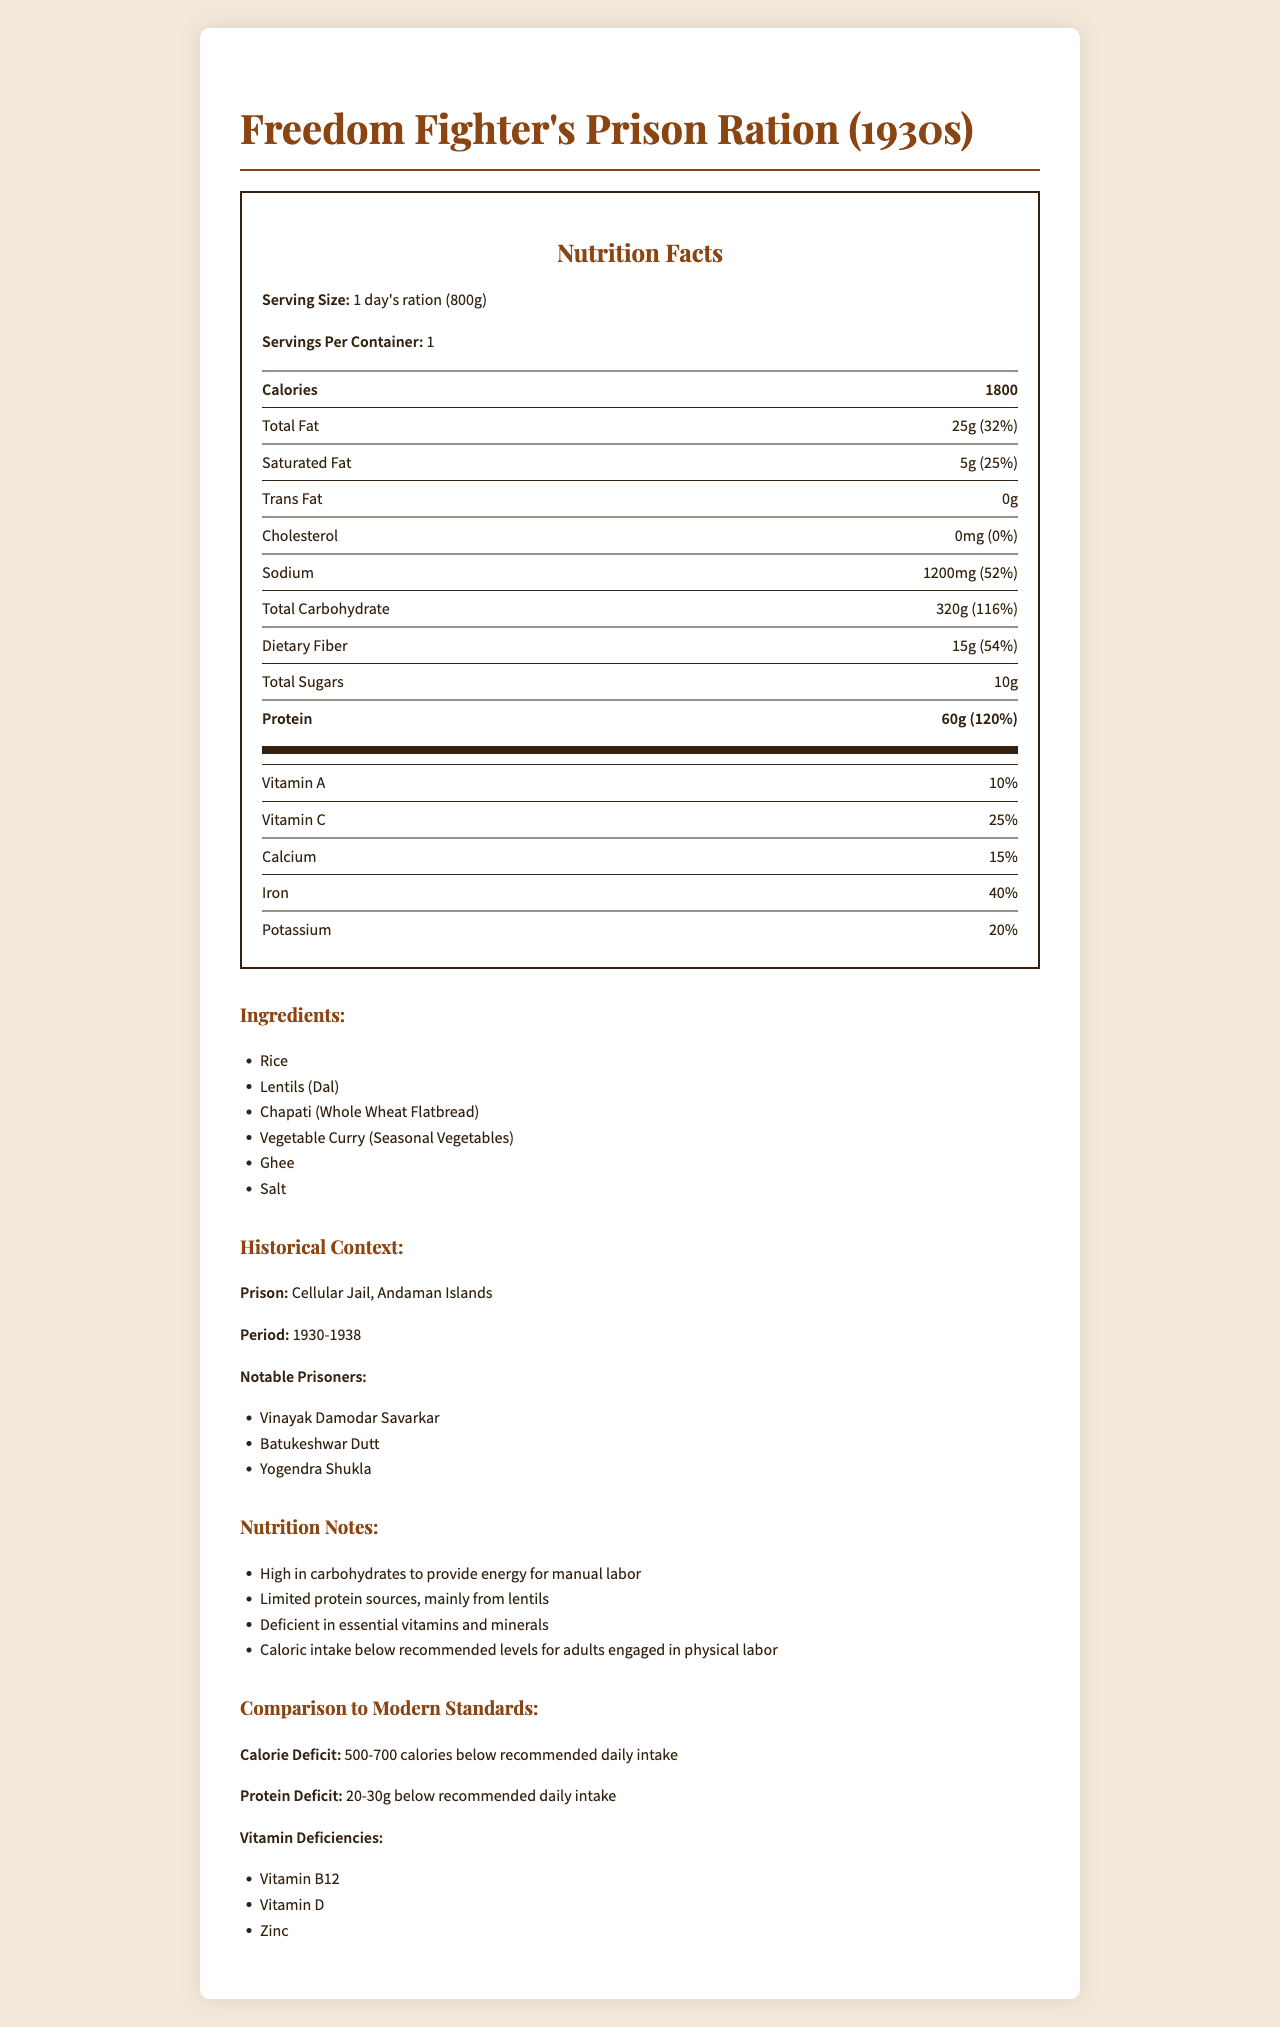what is the serving size for the prison ration? The document specifies under "Serving Size" that it is 1 day's ration weighting 800 grams.
Answer: 1 day's ration (800g) How many calories are in one day's ration? The document states that the total calorie count is 1800.
Answer: 1800 What percentage of daily value of protein does the ration provide? According to the "Nutrition Facts" section, the ration provides 60g of protein which is 120% of the daily value.
Answer: 120% What is the historical context of this prison ration? The "Historical Context" section mentions the prison is Cellular Jail on Andaman Islands and the period is 1930-1938.
Answer: Cellular Jail, Andaman Islands, 1930-1938 Which notable freedom fighter was imprisoned at Cellular Jail? The "Historical Context" section lists Vinayak Damodar Savarkar as one of the notable prisoners.
Answer: Vinayak Damodar Savarkar What is the total amount of fat in the ration? The "Nutrition Facts" section indicates that the total fat content is 25g.
Answer: 25g Does the ration provide any cholesterol? The document shows "Cholesterol: 0mg" and "Daily Value: 0%".
Answer: No How does the sodium content of the ration compare to modern daily recommendations? The "Nutrition Facts" section shows the sodium content is 1200mg which is 52% of the daily value.
Answer: It is high, at 52% of the daily value. What are the main ingredients of the ration? A. Rice, Potatoes, Salt B. Rice, Lentils, Chapati, Vegetable Curry, Ghee, Salt C. Wheat, Lentils, Sugar, Ghee, Salt The document's "Ingredients" section lists Rice, Lentils (Dal), Chapati (Whole Wheat Flatbread), Vegetable Curry (Seasonal Vegetables), Ghee, and Salt.
Answer: B Which of the following vitamins is deficient in the ration according to modern standards? i. Vitamin A ii. Vitamin C iii. Vitamin B12 The "Comparison to Modern Standards" section lists Vitamin B12 deficiency explicitly.
Answer: iii. Vitamin B12 Is the caloric intake provided by the ration sufficient for adults engaged in physical labor? The "Nutrition Notes" section mentions that the caloric intake is below recommended levels for adults engaged in physical labor.
Answer: No Summarize the main idea of the document. The document covers various aspects of the prison ration including its nutritional breakdown, ingredients, historical context involving notable prisoners, and comparisons to modern standards that highlight calorie and nutrient deficiencies.
Answer: The document provides detailed nutrition facts for a prison ration given to freedom fighters in the 1930s at Cellular Jail, Andaman Islands, including caloric intake, macronutrients, vitamins, and minerals, along with a historical context and comparison to modern dietary standards indicating deficiencies and insufficiencies. What is the origin of ingredients like ghee and salt in the ration? The document doesn’t provide information about the origin of ingredients such as ghee and salt in the ration.
Answer: Not enough information 